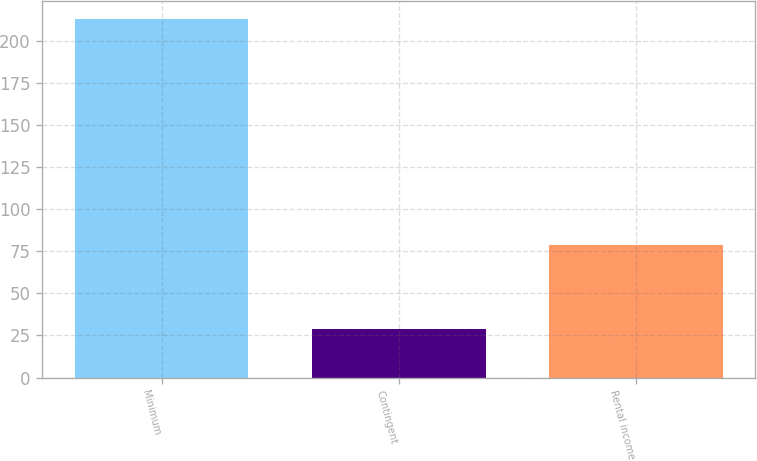Convert chart. <chart><loc_0><loc_0><loc_500><loc_500><bar_chart><fcel>Minimum<fcel>Contingent<fcel>Rental income<nl><fcel>213<fcel>29<fcel>79<nl></chart> 